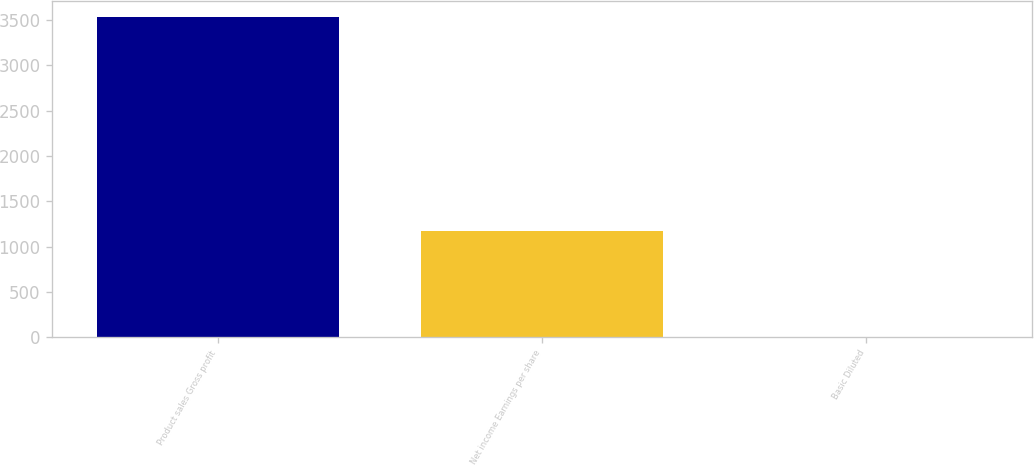Convert chart to OTSL. <chart><loc_0><loc_0><loc_500><loc_500><bar_chart><fcel>Product sales Gross profit<fcel>Net income Earnings per share<fcel>Basic Diluted<nl><fcel>3528<fcel>1167<fcel>1.18<nl></chart> 